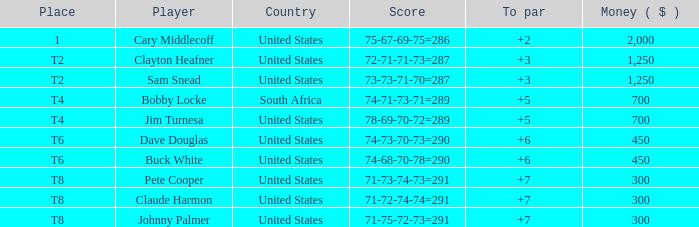What is claude harmon's position? T8. 